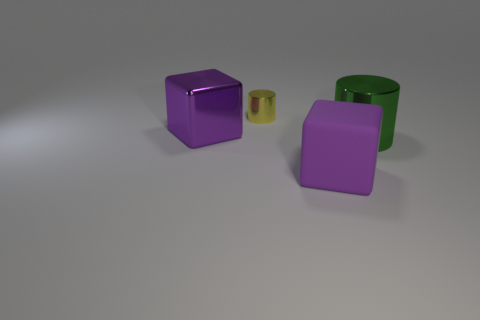Add 3 blocks. How many objects exist? 7 Add 3 small cylinders. How many small cylinders are left? 4 Add 4 green cylinders. How many green cylinders exist? 5 Subtract all yellow cylinders. How many cylinders are left? 1 Subtract 0 green spheres. How many objects are left? 4 Subtract all red cylinders. Subtract all green spheres. How many cylinders are left? 2 Subtract all gray balls. How many green cylinders are left? 1 Subtract all green objects. Subtract all big matte cubes. How many objects are left? 2 